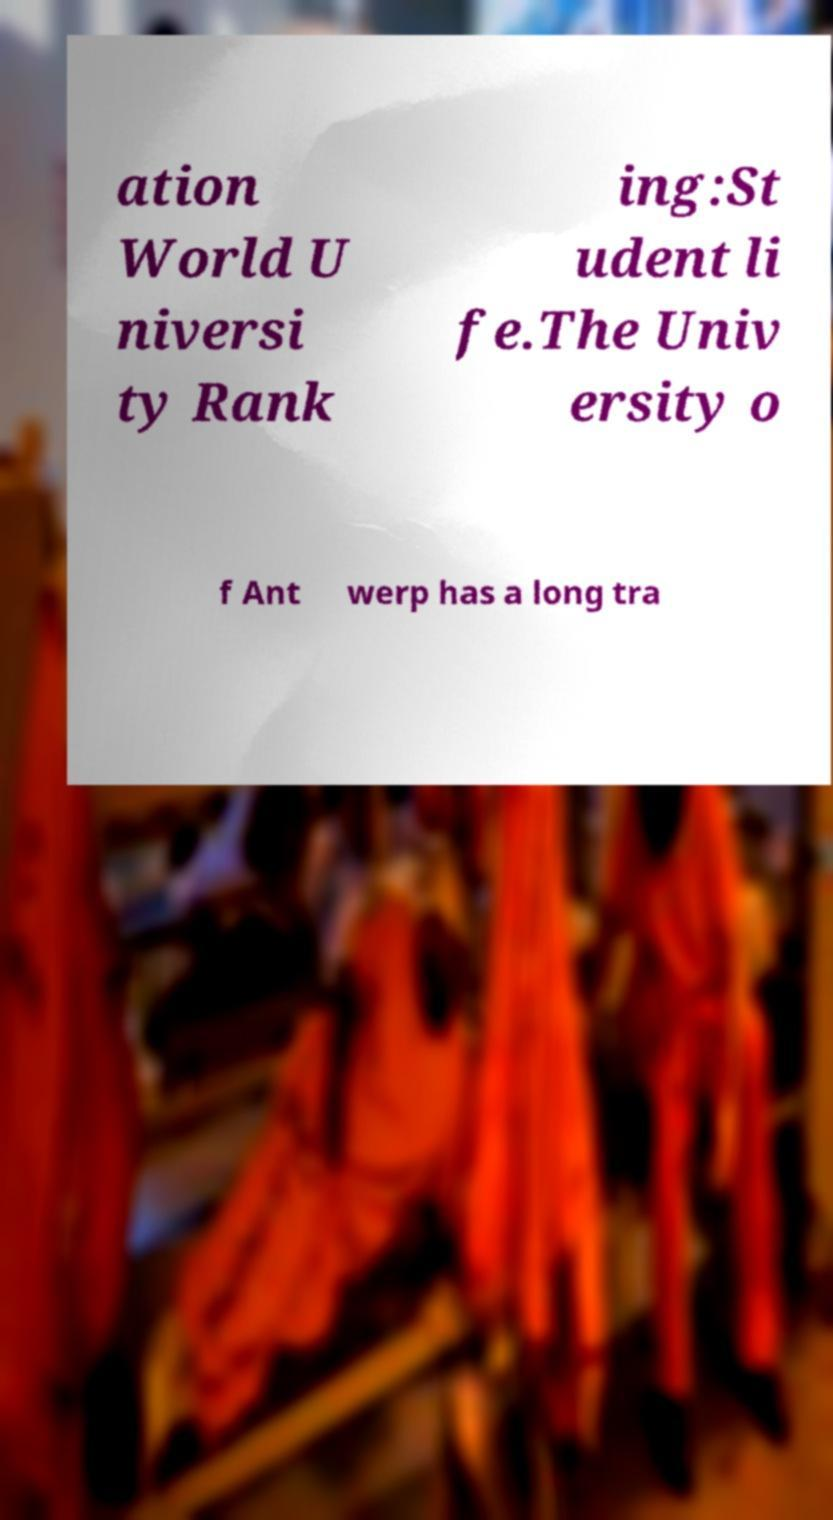Could you extract and type out the text from this image? ation World U niversi ty Rank ing:St udent li fe.The Univ ersity o f Ant werp has a long tra 